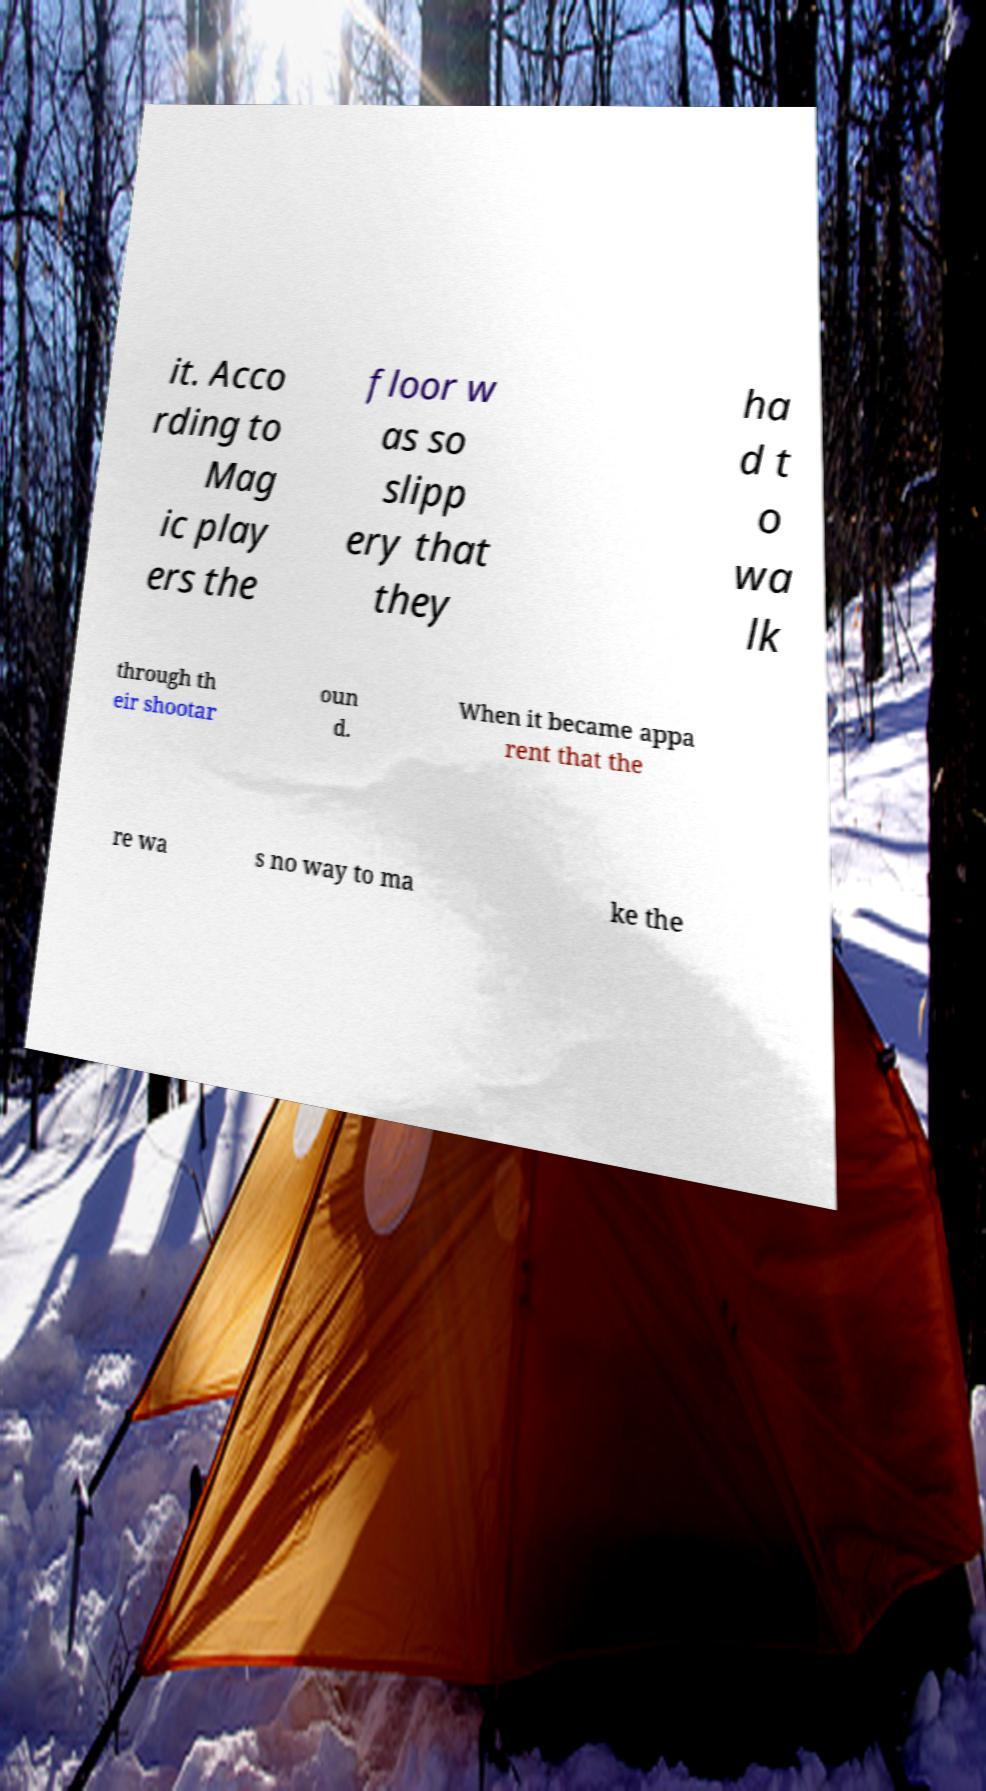What messages or text are displayed in this image? I need them in a readable, typed format. it. Acco rding to Mag ic play ers the floor w as so slipp ery that they ha d t o wa lk through th eir shootar oun d. When it became appa rent that the re wa s no way to ma ke the 